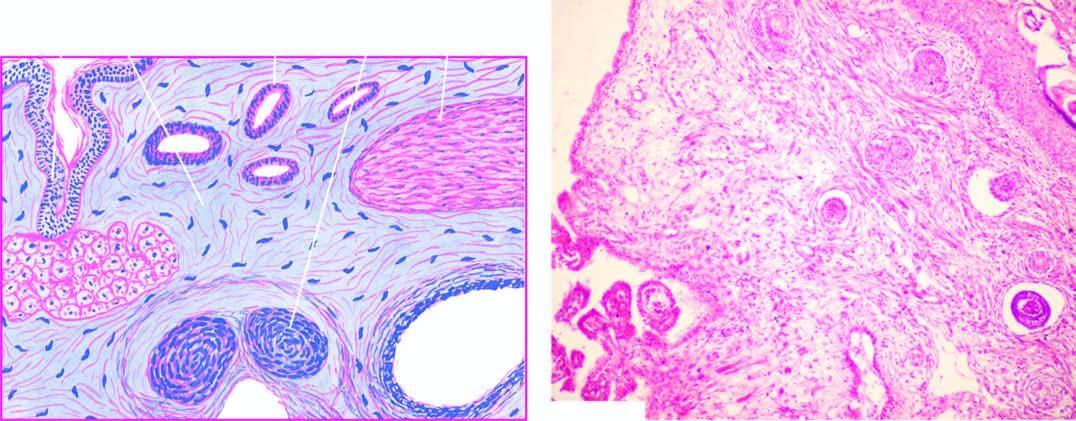what does microscopy show?
Answer the question using a single word or phrase. A variety of incompletely differentiated tissue elements 